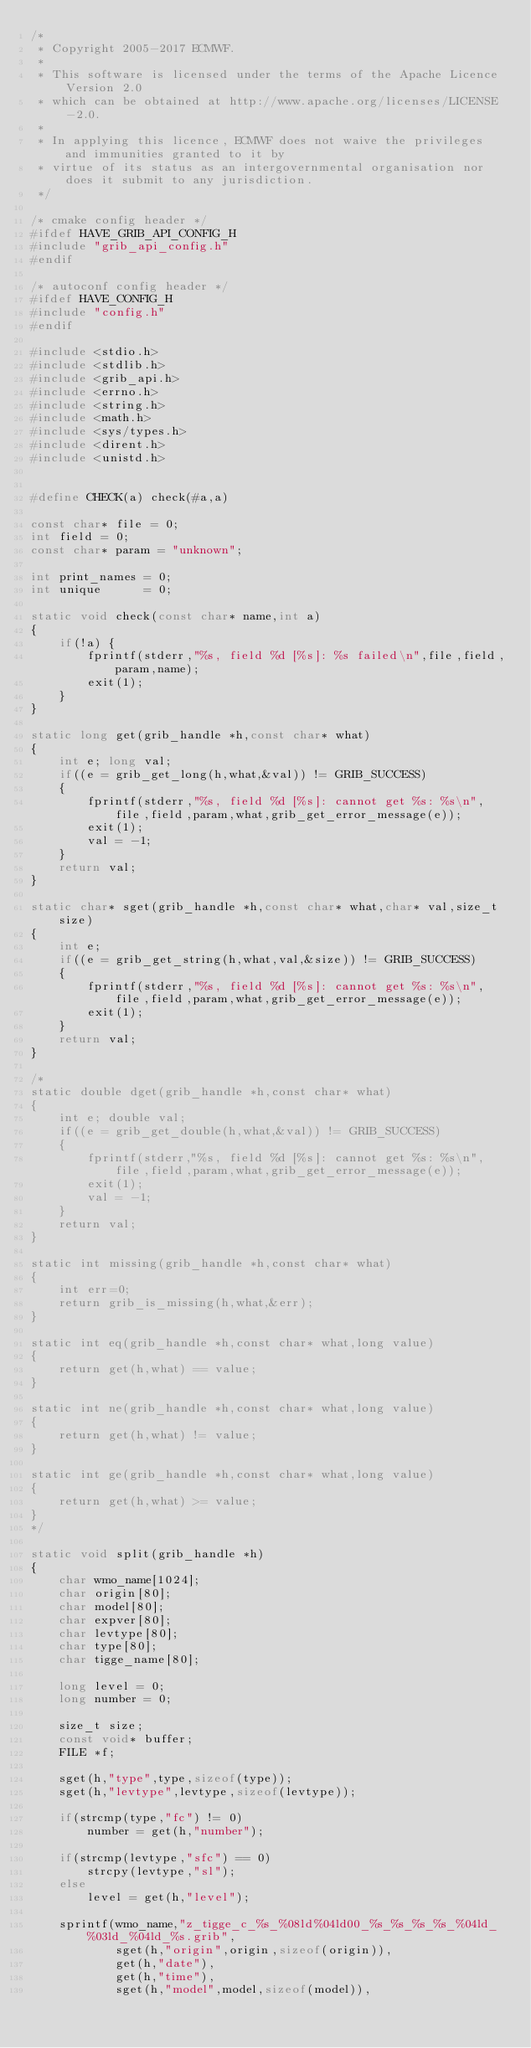<code> <loc_0><loc_0><loc_500><loc_500><_C_>/*
 * Copyright 2005-2017 ECMWF.
 *
 * This software is licensed under the terms of the Apache Licence Version 2.0
 * which can be obtained at http://www.apache.org/licenses/LICENSE-2.0.
 *
 * In applying this licence, ECMWF does not waive the privileges and immunities granted to it by
 * virtue of its status as an intergovernmental organisation nor does it submit to any jurisdiction.
 */

/* cmake config header */
#ifdef HAVE_GRIB_API_CONFIG_H
#include "grib_api_config.h"
#endif

/* autoconf config header */
#ifdef HAVE_CONFIG_H
#include "config.h"
#endif

#include <stdio.h>
#include <stdlib.h>
#include <grib_api.h>
#include <errno.h>
#include <string.h>
#include <math.h>
#include <sys/types.h>
#include <dirent.h>
#include <unistd.h>


#define CHECK(a) check(#a,a)

const char* file = 0;
int field = 0;
const char* param = "unknown";

int print_names = 0;
int unique      = 0;

static void check(const char* name,int a)
{
    if(!a) {
        fprintf(stderr,"%s, field %d [%s]: %s failed\n",file,field,param,name);
        exit(1);
    }
}

static long get(grib_handle *h,const char* what)
{
    int e; long val;
    if((e = grib_get_long(h,what,&val)) != GRIB_SUCCESS)
    {
        fprintf(stderr,"%s, field %d [%s]: cannot get %s: %s\n",file,field,param,what,grib_get_error_message(e));
        exit(1);
        val = -1;
    }
    return val;
}

static char* sget(grib_handle *h,const char* what,char* val,size_t size)
{
    int e;
    if((e = grib_get_string(h,what,val,&size)) != GRIB_SUCCESS)
    {
        fprintf(stderr,"%s, field %d [%s]: cannot get %s: %s\n",file,field,param,what,grib_get_error_message(e));
        exit(1);
    }
    return val;
}

/*
static double dget(grib_handle *h,const char* what)
{
    int e; double val;
    if((e = grib_get_double(h,what,&val)) != GRIB_SUCCESS)
    {
        fprintf(stderr,"%s, field %d [%s]: cannot get %s: %s\n",file,field,param,what,grib_get_error_message(e));
        exit(1);
        val = -1;
    }
    return val;
}

static int missing(grib_handle *h,const char* what)
{
    int err=0;
    return grib_is_missing(h,what,&err);
}

static int eq(grib_handle *h,const char* what,long value)
{
    return get(h,what) == value;
}

static int ne(grib_handle *h,const char* what,long value)
{
    return get(h,what) != value;
}

static int ge(grib_handle *h,const char* what,long value)
{
    return get(h,what) >= value;
}
*/

static void split(grib_handle *h)
{
    char wmo_name[1024];
    char origin[80];
    char model[80];
    char expver[80];
    char levtype[80];
    char type[80];
    char tigge_name[80];

    long level = 0;
    long number = 0;

    size_t size;
    const void* buffer;
    FILE *f;

    sget(h,"type",type,sizeof(type));
    sget(h,"levtype",levtype,sizeof(levtype));

    if(strcmp(type,"fc") != 0)
        number = get(h,"number");

    if(strcmp(levtype,"sfc") == 0)
        strcpy(levtype,"sl");
    else
        level = get(h,"level");

    sprintf(wmo_name,"z_tigge_c_%s_%08ld%04ld00_%s_%s_%s_%s_%04ld_%03ld_%04ld_%s.grib",
            sget(h,"origin",origin,sizeof(origin)),
            get(h,"date"),
            get(h,"time"),
            sget(h,"model",model,sizeof(model)),</code> 